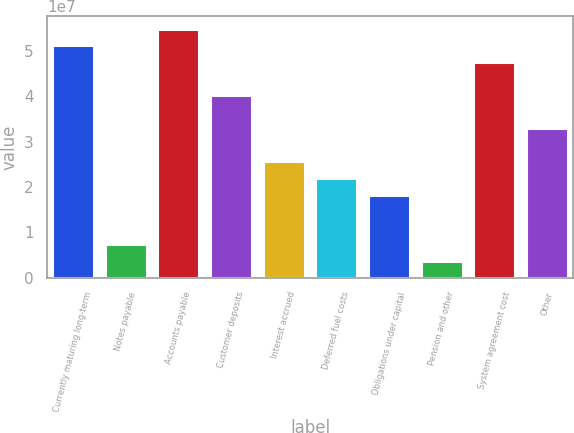Convert chart to OTSL. <chart><loc_0><loc_0><loc_500><loc_500><bar_chart><fcel>Currently maturing long-term<fcel>Notes payable<fcel>Accounts payable<fcel>Customer deposits<fcel>Interest accrued<fcel>Deferred fuel costs<fcel>Obligations under capital<fcel>Pension and other<fcel>System agreement cost<fcel>Other<nl><fcel>5.12626e+07<fcel>7.32535e+06<fcel>5.4924e+07<fcel>4.02783e+07<fcel>2.56325e+07<fcel>2.19711e+07<fcel>1.83096e+07<fcel>3.66392e+06<fcel>4.76011e+07<fcel>3.29554e+07<nl></chart> 